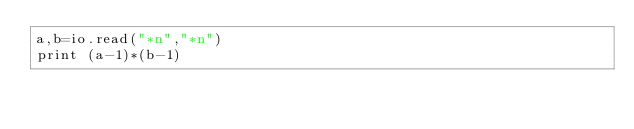Convert code to text. <code><loc_0><loc_0><loc_500><loc_500><_MoonScript_>a,b=io.read("*n","*n")
print (a-1)*(b-1)</code> 